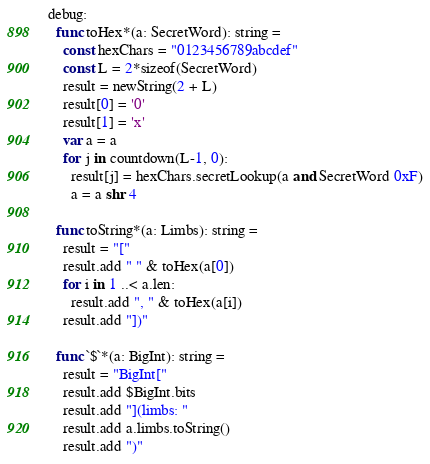<code> <loc_0><loc_0><loc_500><loc_500><_Nim_>debug:
  func toHex*(a: SecretWord): string =
    const hexChars = "0123456789abcdef"
    const L = 2*sizeof(SecretWord)
    result = newString(2 + L)
    result[0] = '0'
    result[1] = 'x'
    var a = a
    for j in countdown(L-1, 0):
      result[j] = hexChars.secretLookup(a and SecretWord 0xF)
      a = a shr 4

  func toString*(a: Limbs): string =
    result = "["
    result.add " " & toHex(a[0])
    for i in 1 ..< a.len:
      result.add ", " & toHex(a[i])
    result.add "])"

  func `$`*(a: BigInt): string =
    result = "BigInt["
    result.add $BigInt.bits
    result.add "](limbs: "
    result.add a.limbs.toString()
    result.add ")"
</code> 